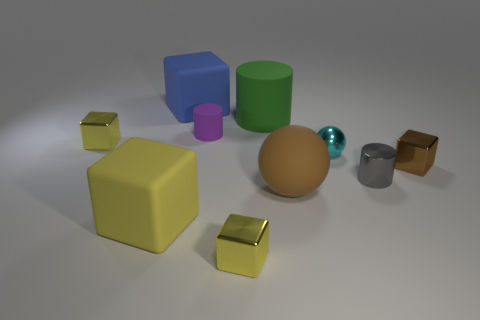The ball that is made of the same material as the big cylinder is what size?
Your response must be concise. Large. Is the number of matte cubes in front of the tiny brown object greater than the number of small brown things right of the tiny gray shiny object?
Make the answer very short. No. How many other objects are the same material as the big yellow block?
Your answer should be very brief. 4. Is the material of the small gray cylinder that is behind the large ball the same as the blue block?
Offer a terse response. No. What is the shape of the large green rubber object?
Provide a short and direct response. Cylinder. Are there more big green cylinders that are in front of the brown metal block than tiny metal things?
Provide a succinct answer. No. Are there any other things that have the same shape as the tiny brown object?
Your answer should be compact. Yes. There is another tiny metallic thing that is the same shape as the tiny purple object; what color is it?
Give a very brief answer. Gray. There is a blue object behind the brown metal thing; what shape is it?
Your answer should be very brief. Cube. There is a metallic cylinder; are there any shiny cubes in front of it?
Your answer should be very brief. Yes. 